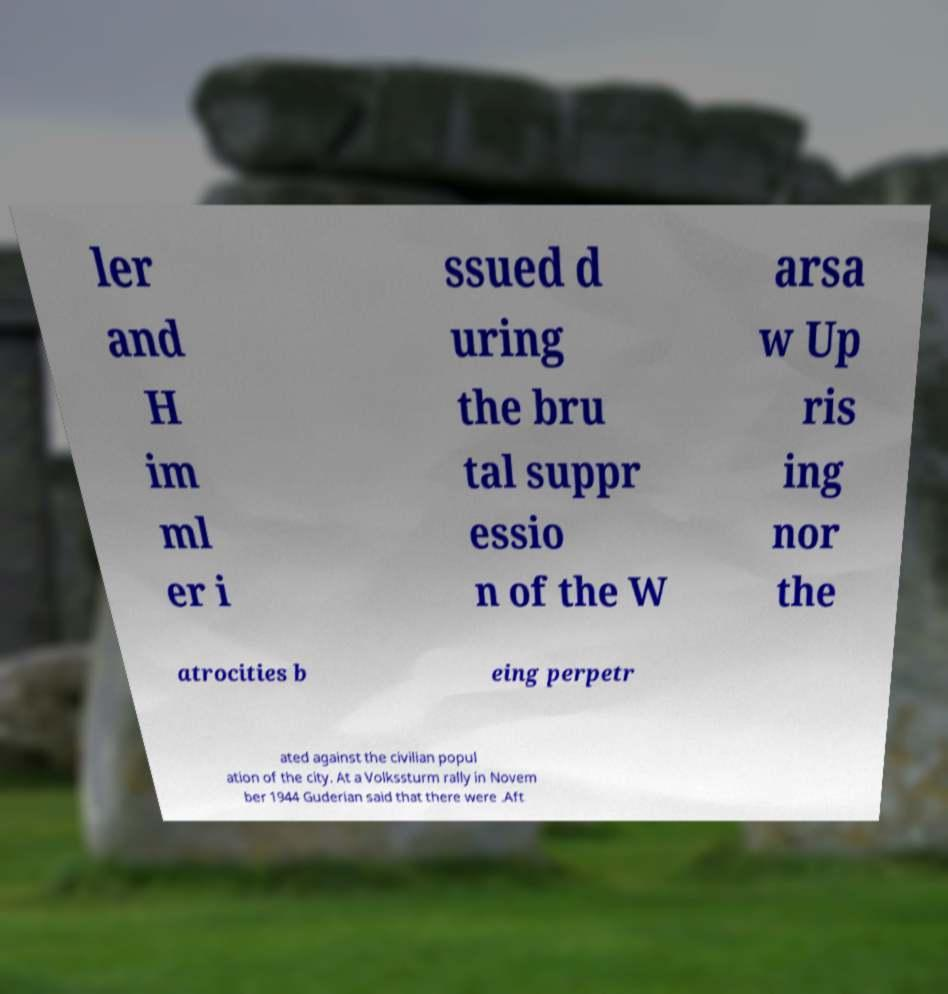Please read and relay the text visible in this image. What does it say? ler and H im ml er i ssued d uring the bru tal suppr essio n of the W arsa w Up ris ing nor the atrocities b eing perpetr ated against the civilian popul ation of the city. At a Volkssturm rally in Novem ber 1944 Guderian said that there were .Aft 